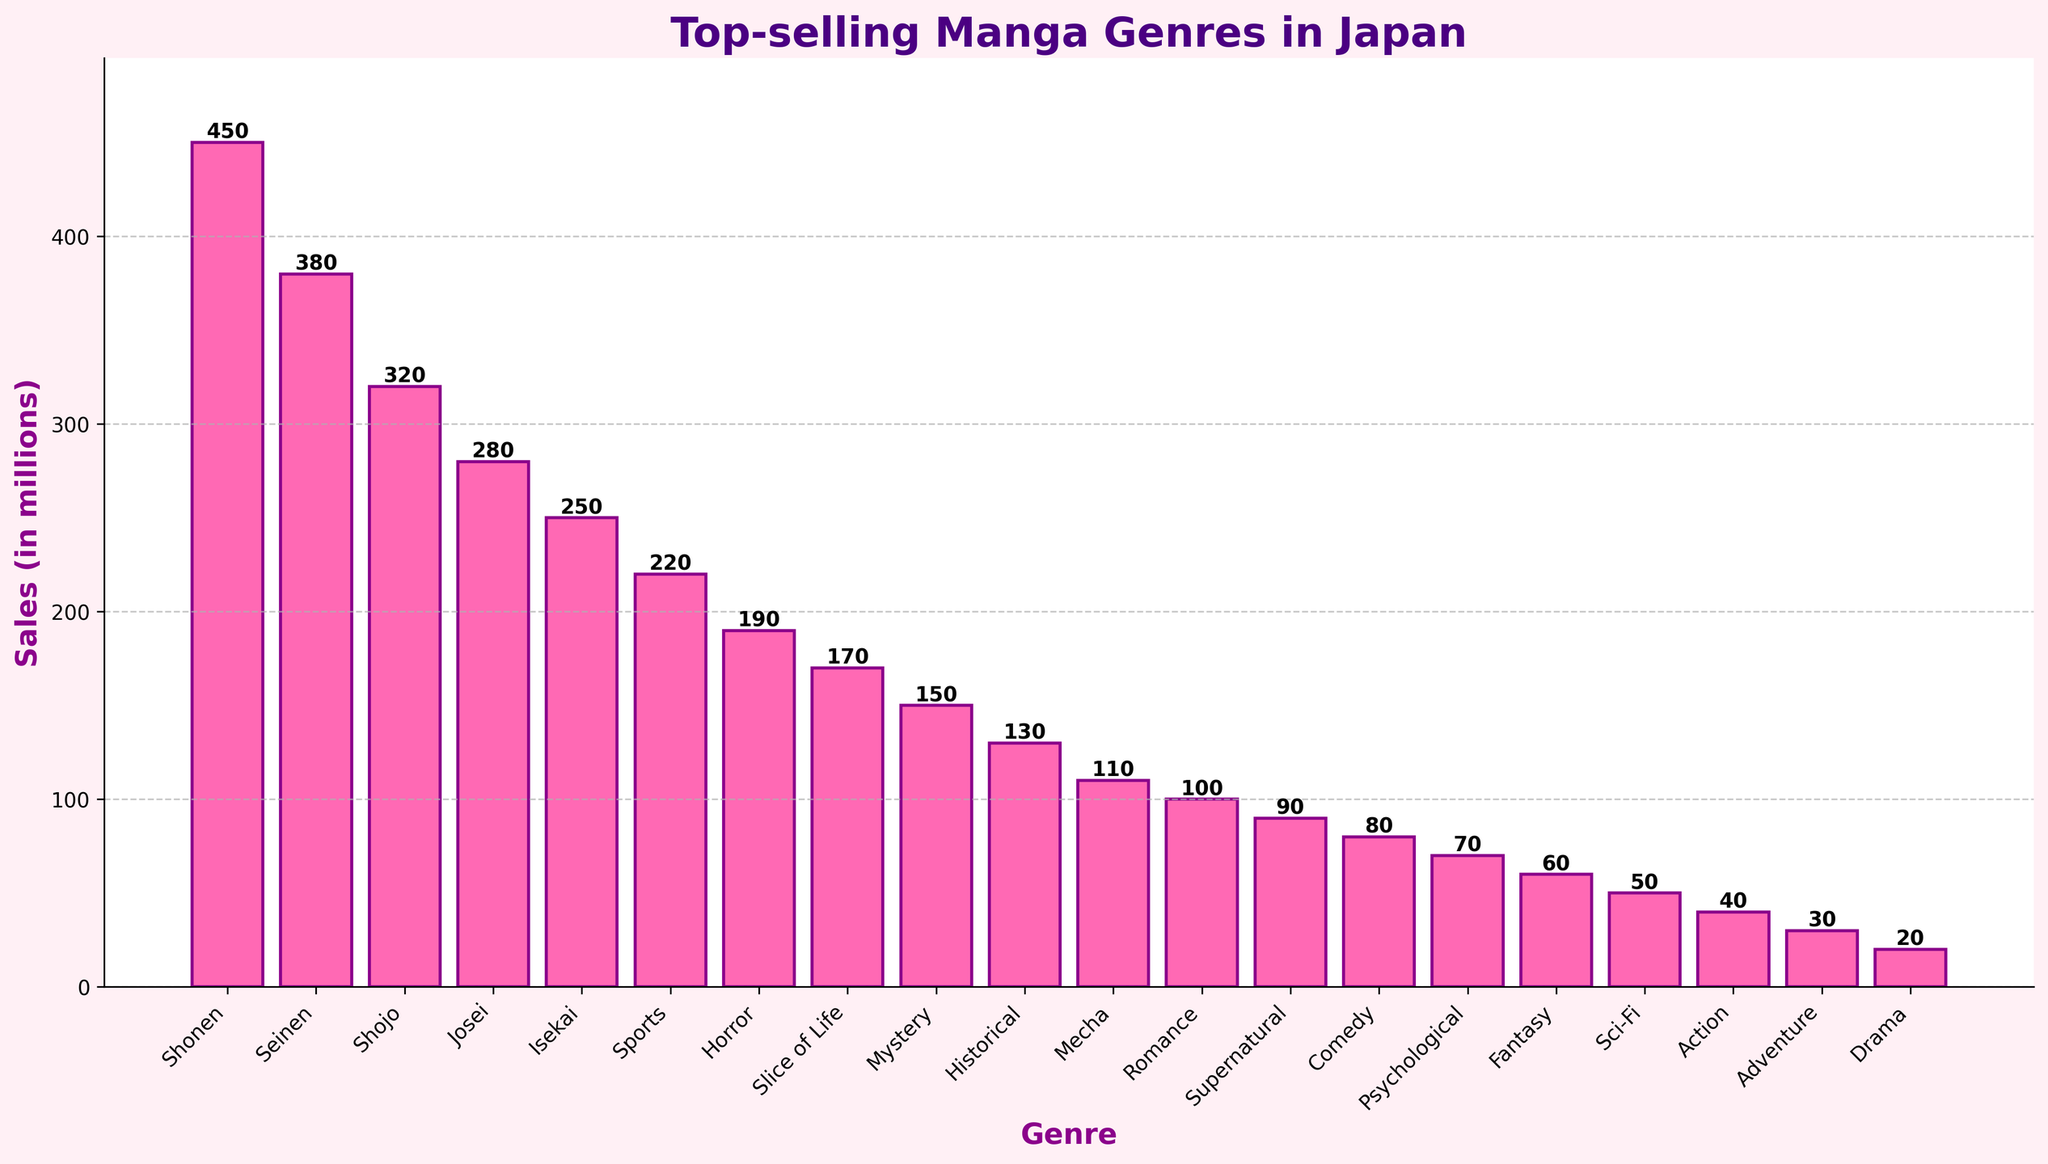Which genre has the highest sales? The highest bar represents the genre with the highest sales, which is "Shonen" with 450 million sales.
Answer: Shonen How much more sales did Shonen have compared to Josei? Shonen has 450 million sales and Josei has 280 million. The difference is 450 - 280 = 170 million.
Answer: 170 million Which genre has the lowest sales, and what are the sales figures? The shortest bar indicates the genre with the lowest sales, which is "Drama" with 20 million sales.
Answer: Drama, 20 million Compare the sales of Seinen and Shojo. Which one is higher and by how much? Seinen has 380 million sales, while Shojo has 320 million. Seinen's sales are higher by 380 - 320 = 60 million.
Answer: Seinen, 60 million What is the combined sale of Horror and Slice of Life? Horror has 190 million sales and Slice of Life has 170 million. The combined sales are 190 + 170 = 360 million.
Answer: 360 million Rank the genres from highest to lowest sales. The bars arranged from tallest to shortest provide the ranking. The order is: Shonen, Seinen, Shojo, Josei, Isekai, Sports, Horror, Slice of Life, Mystery, Historical, Mecha, Romance, Supernatural, Comedy, Psychological, Fantasy, Sci-Fi, Action, Adventure, Drama.
Answer: Shonen, Seinen, Shojo, Josei, Isekai, Sports, Horror, Slice of Life, Mystery, Historical, Mecha, Romance, Supernatural, Comedy, Psychological, Fantasy, Sci-Fi, Action, Adventure, Drama Which genres have sales less than 100 million? The bars for Romance, Supernatural, Comedy, Psychological, Fantasy, Sci-Fi, Action, Adventure, and Drama are below the 100 million mark.
Answer: Romance, Supernatural, Comedy, Psychological, Fantasy, Sci-Fi, Action, Adventure, Drama What percentage of the total sales does Shonen represent? First, calculate the total sales by summing all genres, then divide Shonen's sales by the total and multiply by 100. Total sales (Sum): 450 + 380 + 320 + 280 + 250 + 220 + 190 + 170 + 150 + 130 + 110 + 100 + 90 + 80 + 70 + 60 + 50 + 40 + 30 + 20 = 3360 million. Shonen's percentage = (450 / 3360) * 100 ≈ 13.39%.
Answer: 13.39% By how much do sales of Shonen exceed the combined sales of Fantasy, Sci-Fi, Action, and Drama? Shonen has 450 million sales. Combined sales of Fantasy, Sci-Fi, Action, and Drama are 60 + 50 + 40 + 20 = 170 million. The difference is 450 - 170 = 280 million.
Answer: 280 million Identify the genre with the third highest sales and state the amount. The third highest bar corresponds to "Shojo" with sales of 320 million.
Answer: Shojo, 320 million 